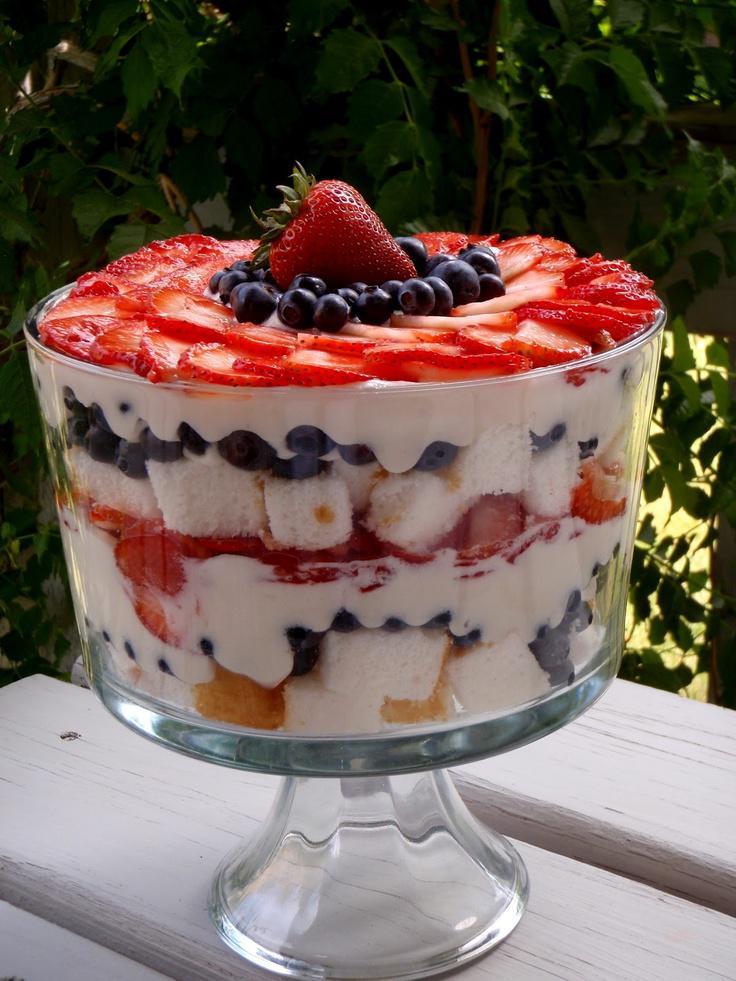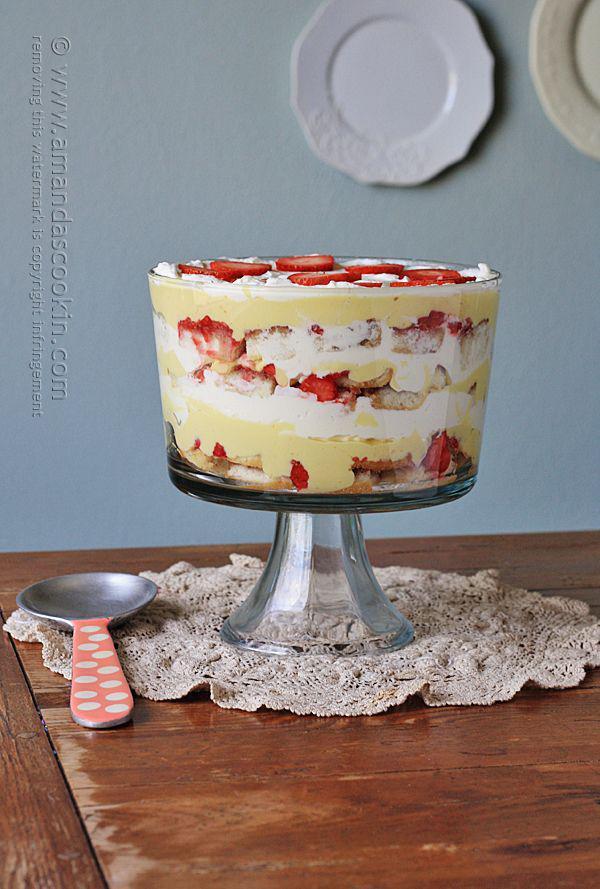The first image is the image on the left, the second image is the image on the right. Evaluate the accuracy of this statement regarding the images: "there are blueberries on the top of the dessert in one of the images.". Is it true? Answer yes or no. Yes. The first image is the image on the left, the second image is the image on the right. Assess this claim about the two images: "Strawberries and blueberries top one of the desserts depicted.". Correct or not? Answer yes or no. Yes. 